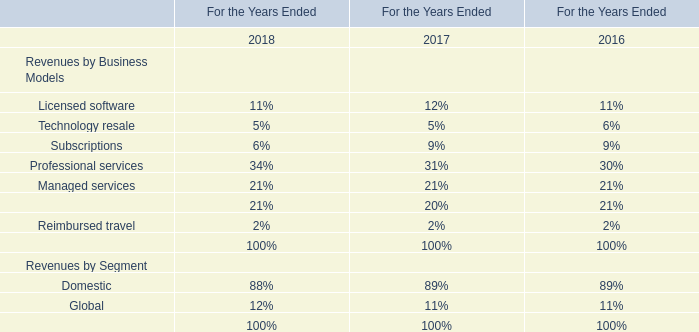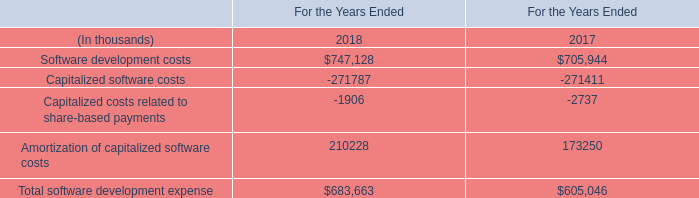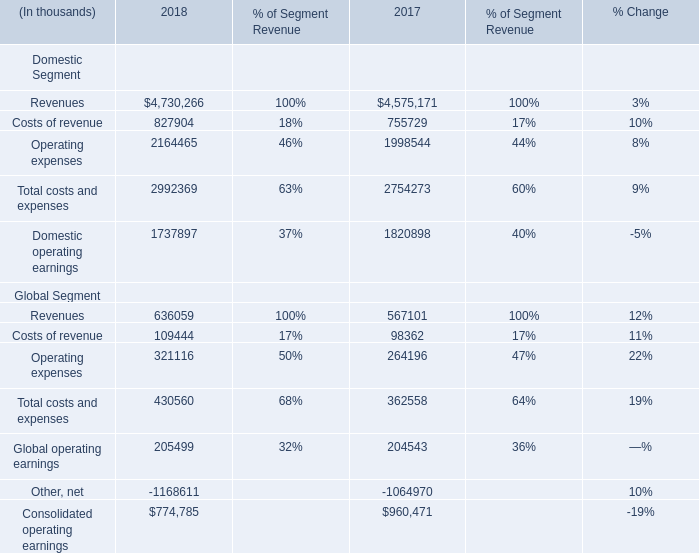what's the total amount of Capitalized software costs of For the Years Ended 2017, and Other, net Global Segment of 2018 ? 
Computations: (271411.0 + 1168611.0)
Answer: 1440022.0. 